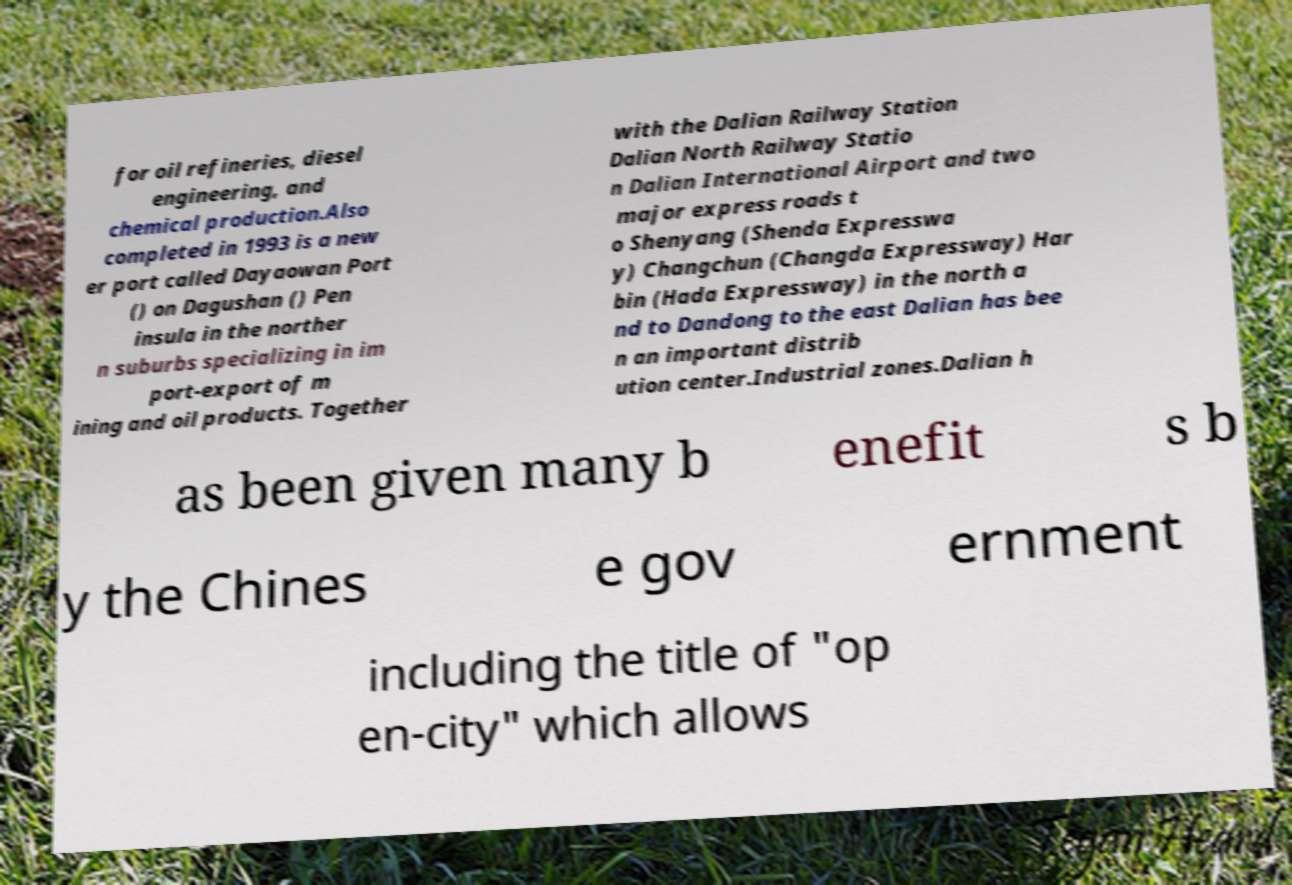Please identify and transcribe the text found in this image. for oil refineries, diesel engineering, and chemical production.Also completed in 1993 is a new er port called Dayaowan Port () on Dagushan () Pen insula in the norther n suburbs specializing in im port-export of m ining and oil products. Together with the Dalian Railway Station Dalian North Railway Statio n Dalian International Airport and two major express roads t o Shenyang (Shenda Expresswa y) Changchun (Changda Expressway) Har bin (Hada Expressway) in the north a nd to Dandong to the east Dalian has bee n an important distrib ution center.Industrial zones.Dalian h as been given many b enefit s b y the Chines e gov ernment including the title of "op en-city" which allows 